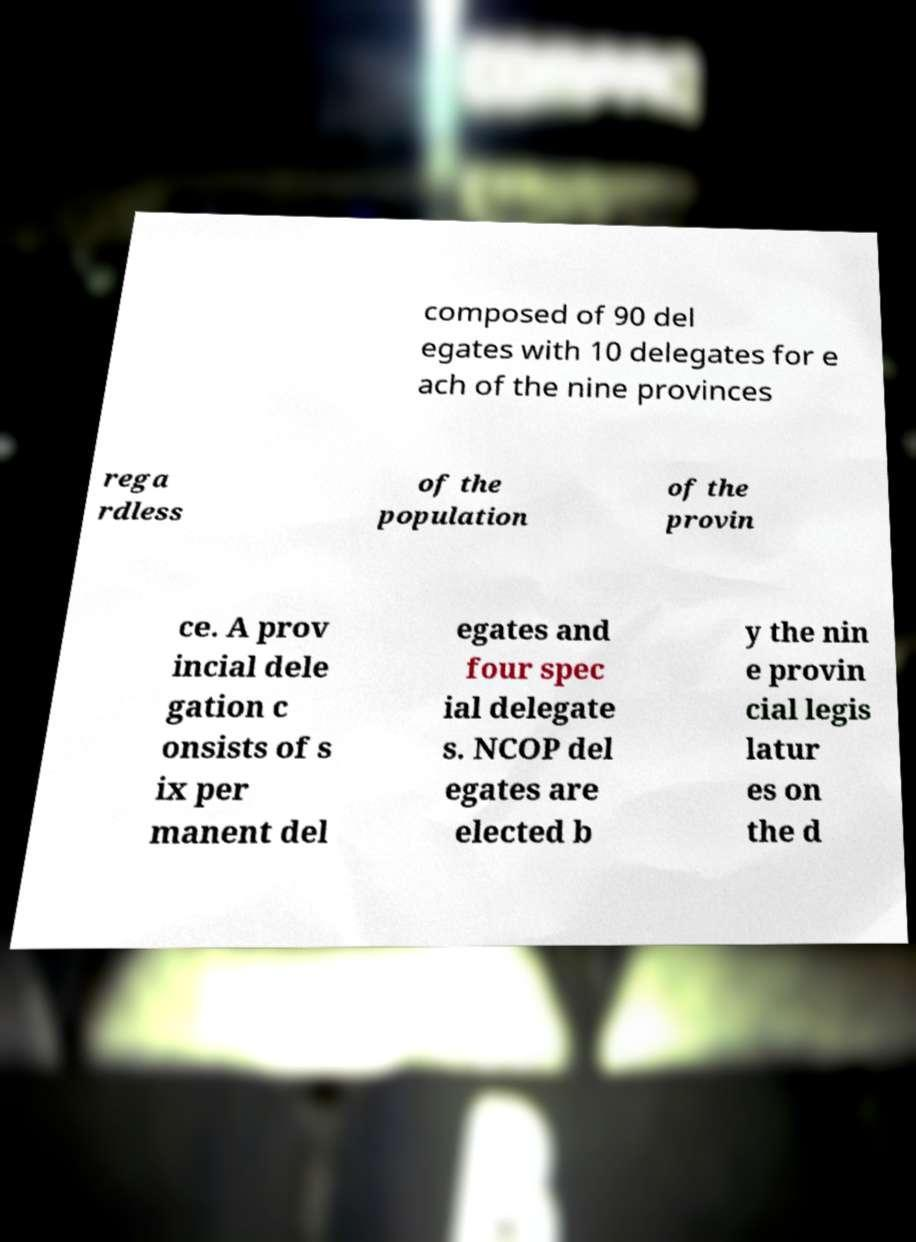I need the written content from this picture converted into text. Can you do that? composed of 90 del egates with 10 delegates for e ach of the nine provinces rega rdless of the population of the provin ce. A prov incial dele gation c onsists of s ix per manent del egates and four spec ial delegate s. NCOP del egates are elected b y the nin e provin cial legis latur es on the d 